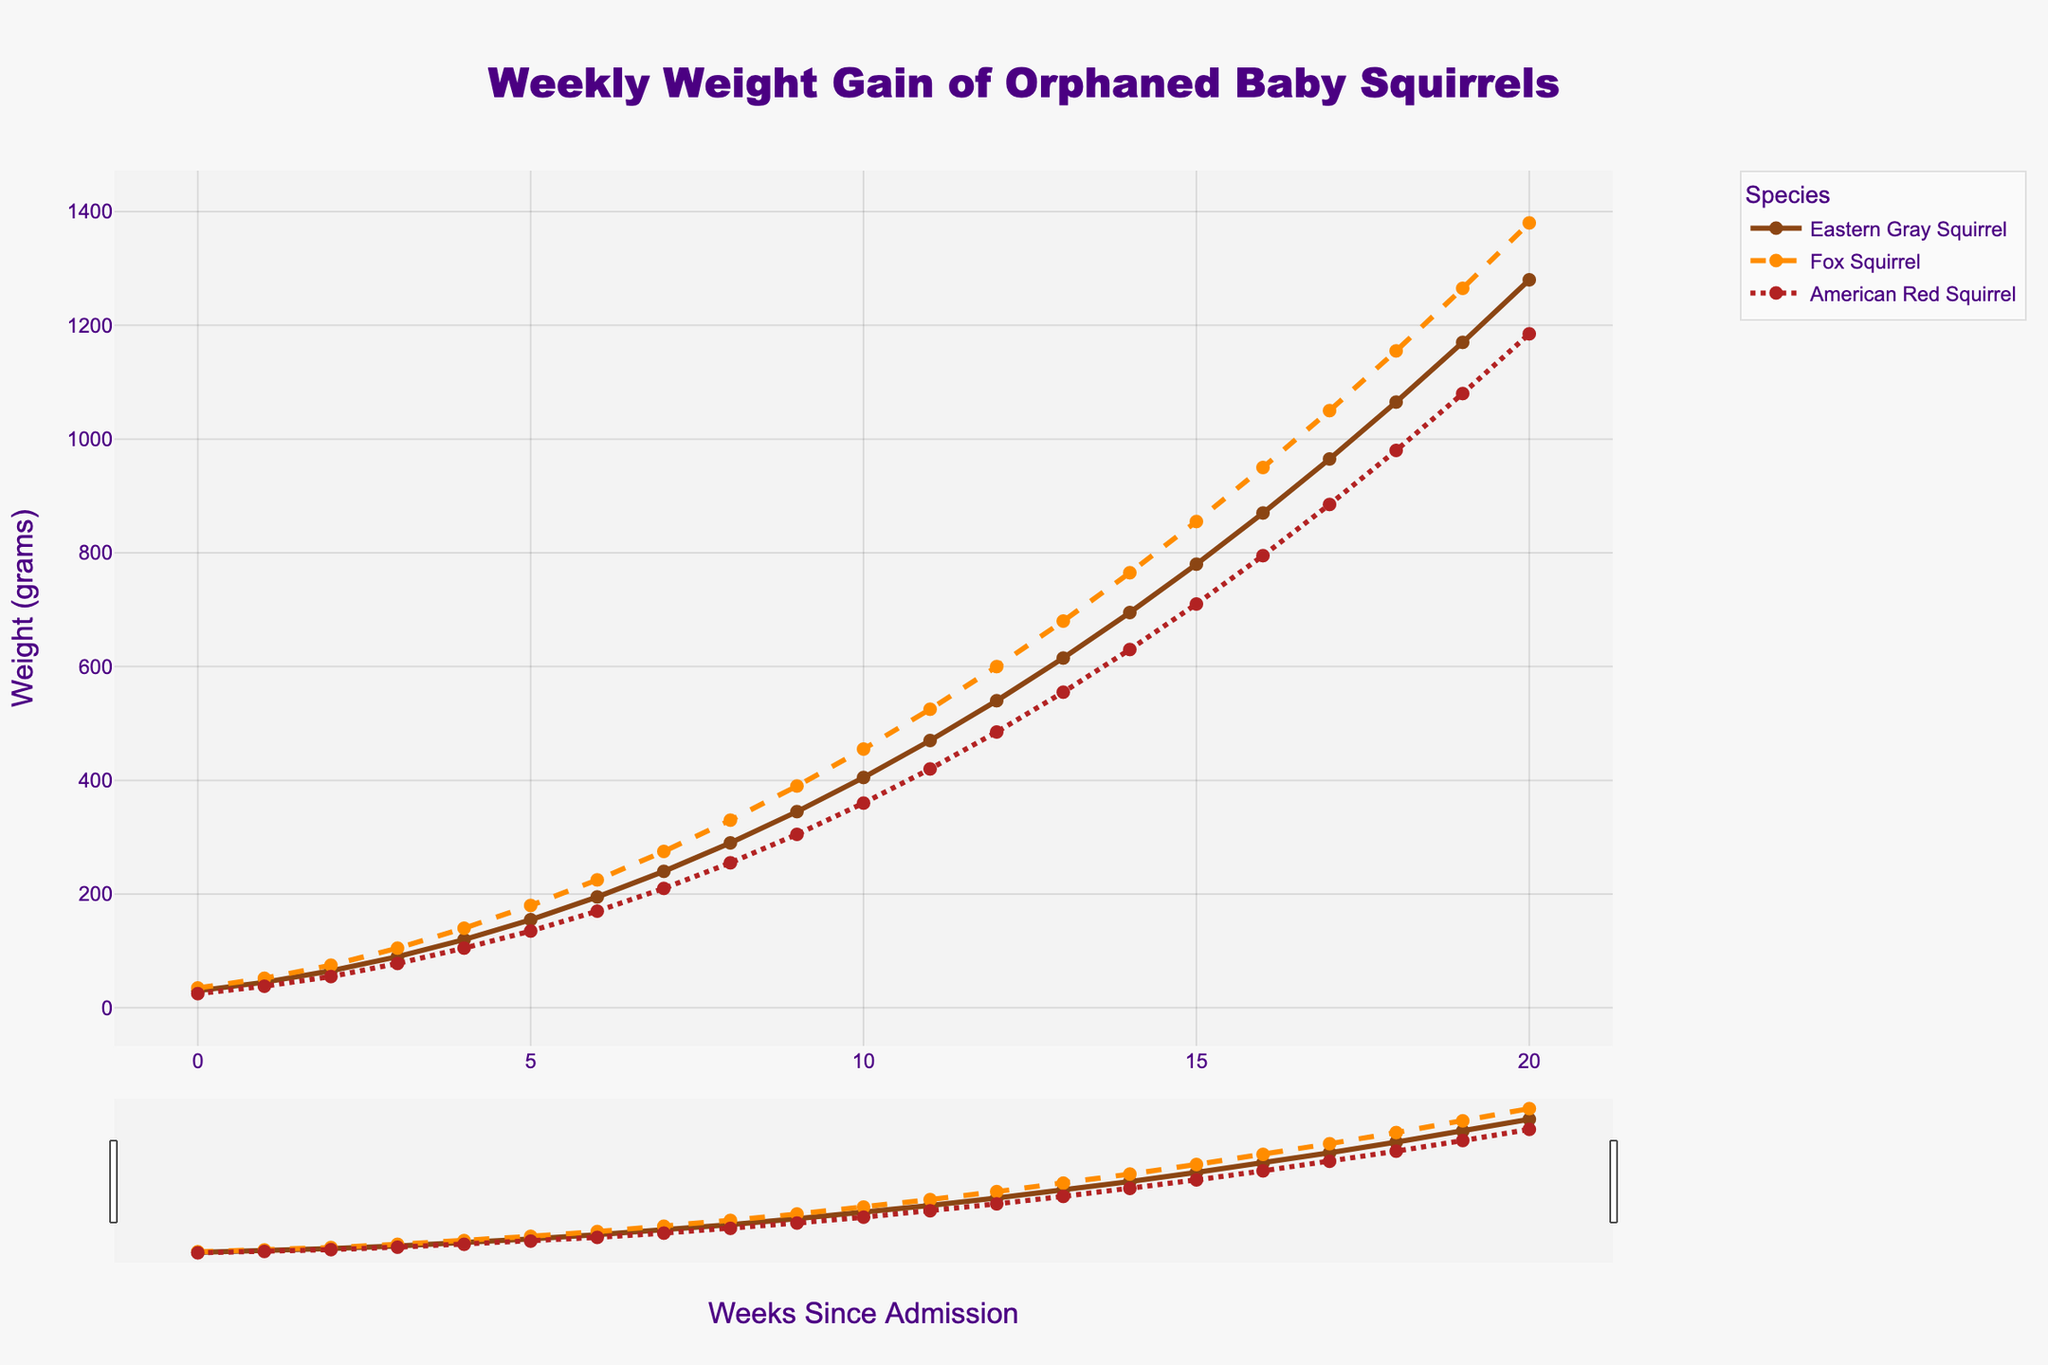What is the total weight gain of the Eastern Gray Squirrel from Week 0 to Week 20? The weight gain from Week 0 to Week 20 for the Eastern Gray Squirrel can be calculated by subtracting the weight at Week 0 from the weight at Week 20: 1280 - 30 = 1250 grams.
Answer: 1250 grams Which species has the most weight at Week 10? By examining the chart, at Week 10, the weights of the Eastern Gray Squirrel, Fox Squirrel, and American Red Squirrel are 405g, 455g, and 360g respectively. The Fox Squirrel has the most weight at this point.
Answer: Fox Squirrel At which week do all species' weights exceed 400 grams for the first time? By checking the chart, the Eastern Gray Squirrel exceeds 400 grams at Week 10, the Fox Squirrel at Week 8, and the American Red Squirrel at Week 11. The first week all species exceed 400 grams is Week 11.
Answer: Week 11 How much more does the Fox Squirrel weigh compared to the American Red Squirrel at Week 15? At Week 15, the Fox Squirrel weighs 855 grams, and the American Red Squirrel weighs 710 grams. The difference is 855 - 710 = 145 grams.
Answer: 145 grams What is the average weight of the American Red Squirrel over the span of Weeks 10 to 15? To find the average, sum the weights of the American Red Squirrel from Week 10 to Week 15 and divide by the number of weeks: (360 + 420 + 485 + 555 + 630 + 710) / 6 = 520 grams.
Answer: 520 grams Do any of the species have weights that consistently increase every week? By observing the chart lines for each species, all three species (Eastern Gray Squirrel, Fox Squirrel, and American Red Squirrel) show a consistent increase in weight every week without any decreases.
Answer: Yes What is the average weight gain per week of the Eastern Gray Squirrel from Week 5 to Week 10? Calculate the total weight gain over the period and then divide by the number of weeks: (405 - 155) / (10 - 5) = 50 grams per week.
Answer: 50 grams per week 